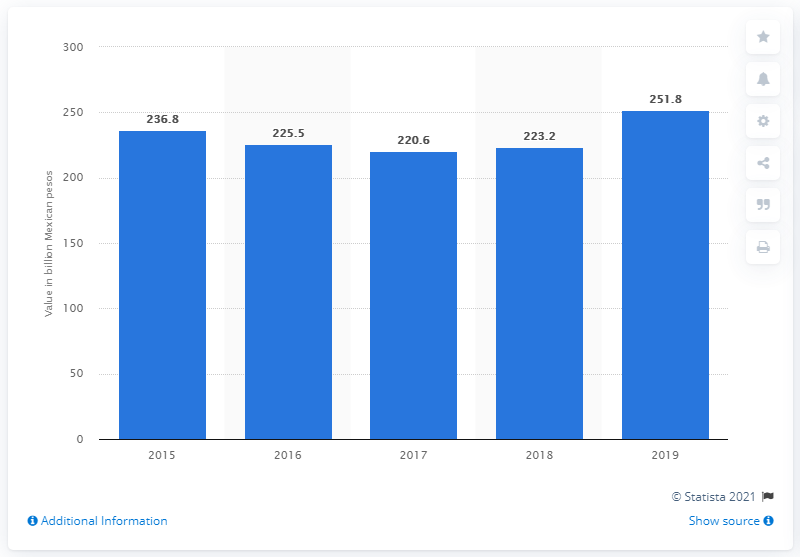Specify some key components in this picture. Mexico's military expenditure began to increase in 2017. In 2019, military spending in Mexico exceeded 251.8 billion pesos. 